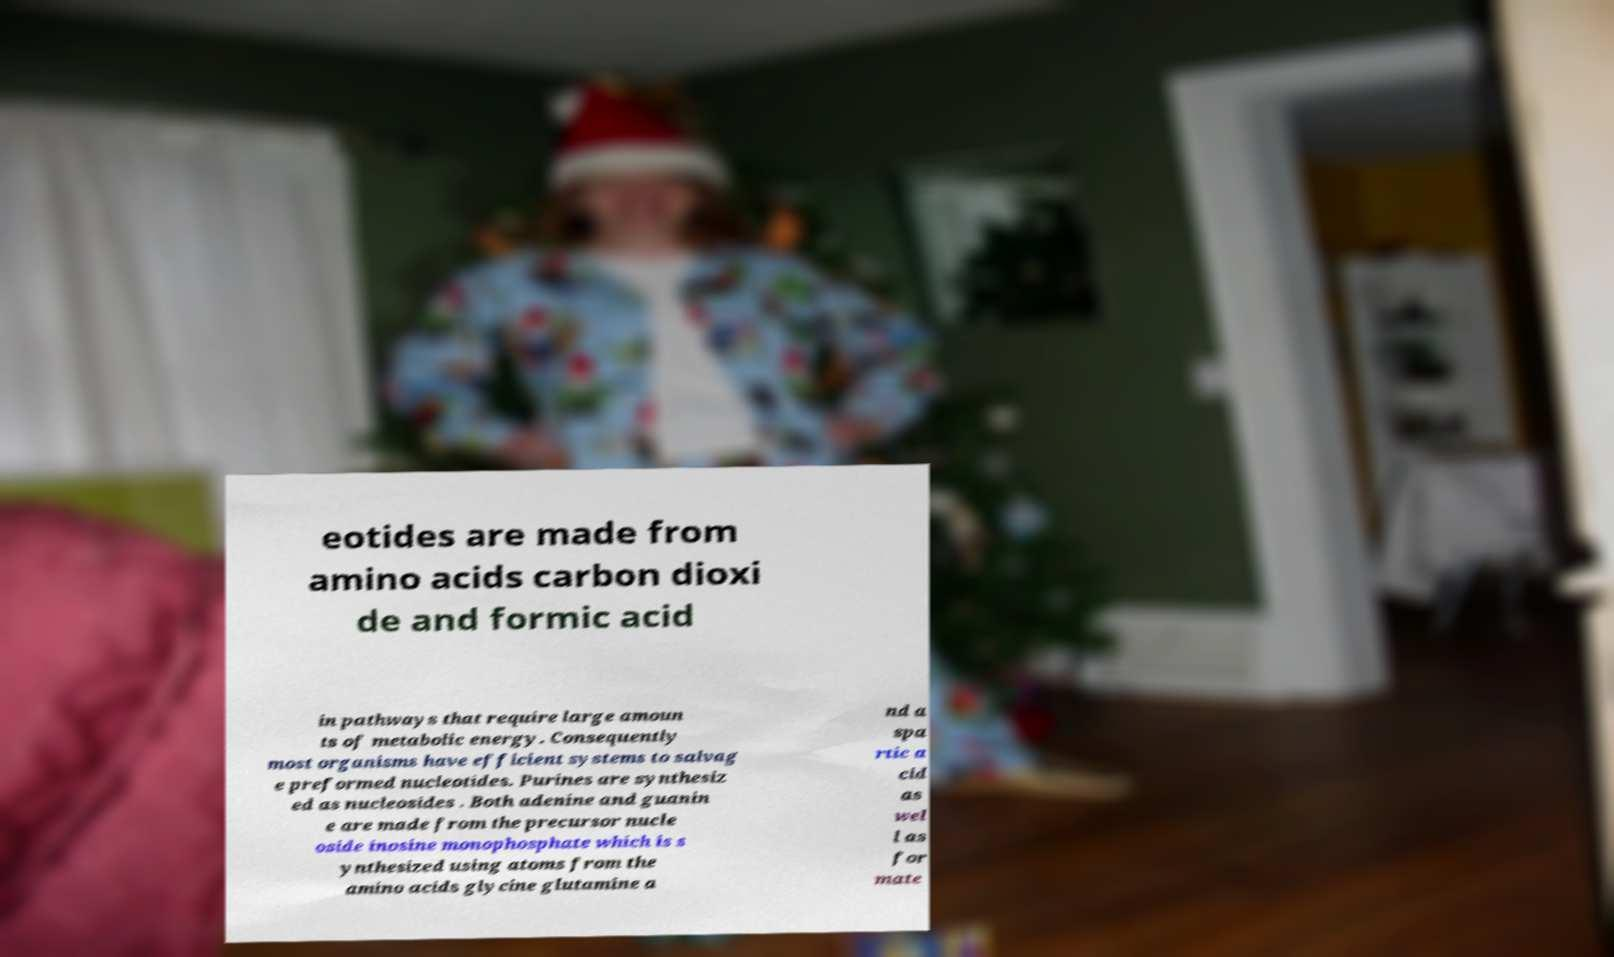Could you extract and type out the text from this image? eotides are made from amino acids carbon dioxi de and formic acid in pathways that require large amoun ts of metabolic energy. Consequently most organisms have efficient systems to salvag e preformed nucleotides. Purines are synthesiz ed as nucleosides . Both adenine and guanin e are made from the precursor nucle oside inosine monophosphate which is s ynthesized using atoms from the amino acids glycine glutamine a nd a spa rtic a cid as wel l as for mate 